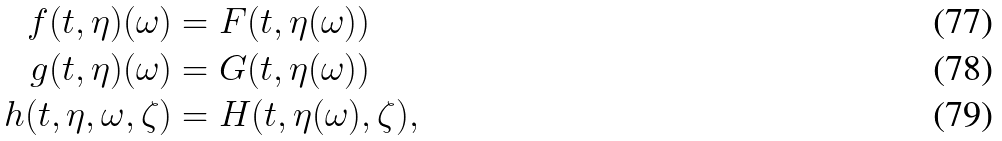<formula> <loc_0><loc_0><loc_500><loc_500>f ( t , \eta ) ( \omega ) & = F ( t , \eta ( \omega ) ) \\ g ( t , \eta ) ( \omega ) & = G ( t , \eta ( \omega ) ) \\ h ( t , \eta , \omega , \zeta ) & = H ( t , \eta ( \omega ) , \zeta ) ,</formula> 